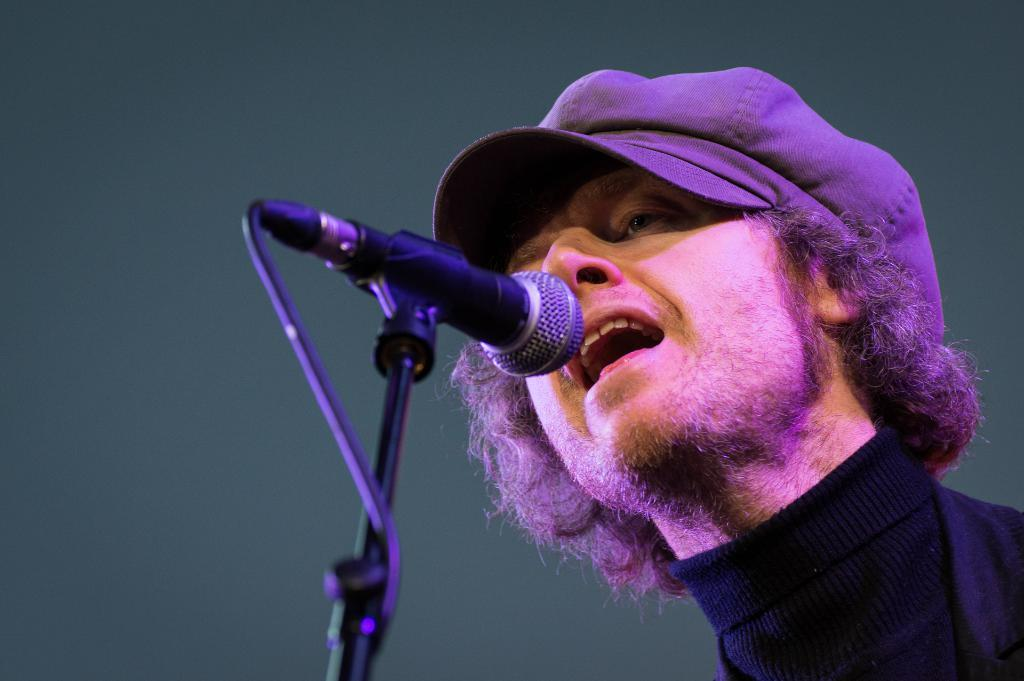Who is present in the image? There is a man in the picture. What is the man wearing on his head? The man is wearing a cap. What object can be seen in the picture that is typically used for amplifying sound? There is a microphone in the picture. What type of boat is the man using for his voyage in the image? There is no boat or voyage present in the image; it features a man wearing a cap and a microphone. 